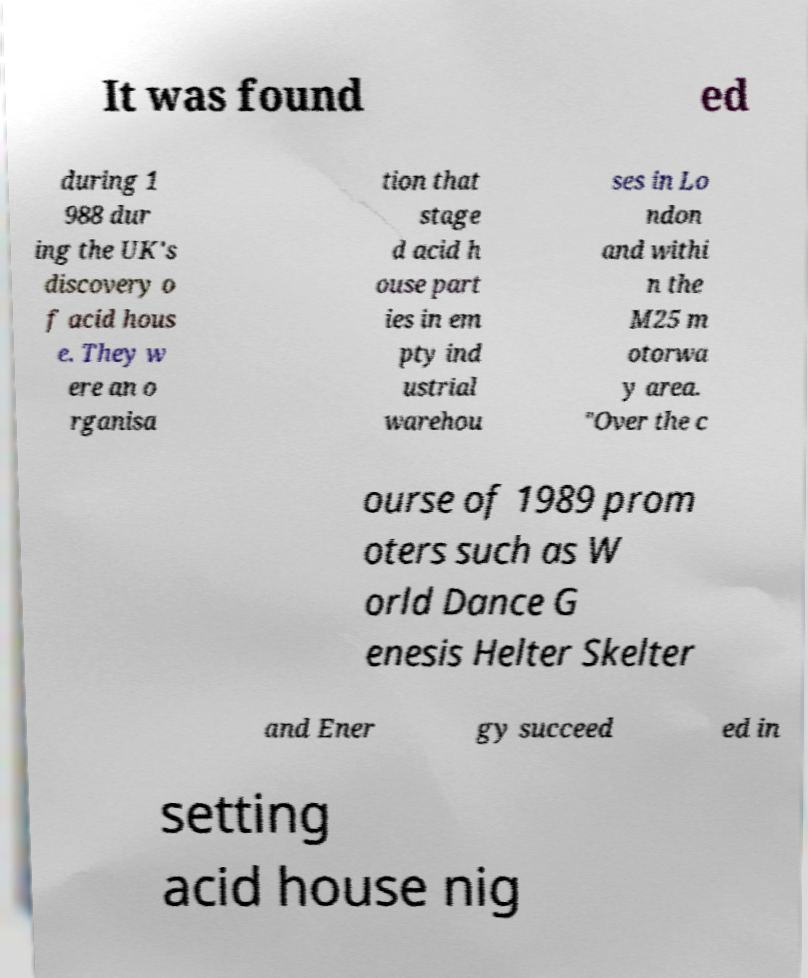Can you accurately transcribe the text from the provided image for me? It was found ed during 1 988 dur ing the UK's discovery o f acid hous e. They w ere an o rganisa tion that stage d acid h ouse part ies in em pty ind ustrial warehou ses in Lo ndon and withi n the M25 m otorwa y area. "Over the c ourse of 1989 prom oters such as W orld Dance G enesis Helter Skelter and Ener gy succeed ed in setting acid house nig 